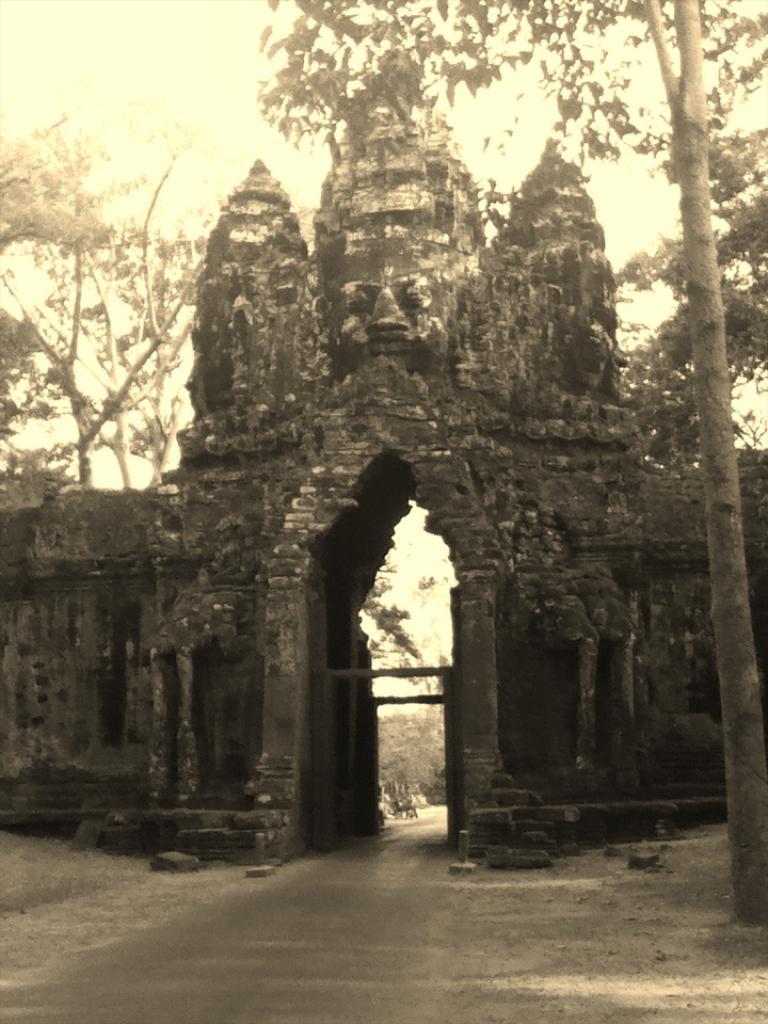Can you describe this image briefly? This is a black and white picture. In the center of the picture there is a sculpture carved out of stone. On the left there is soil. On the right there is a tree. In the background there are trees. 